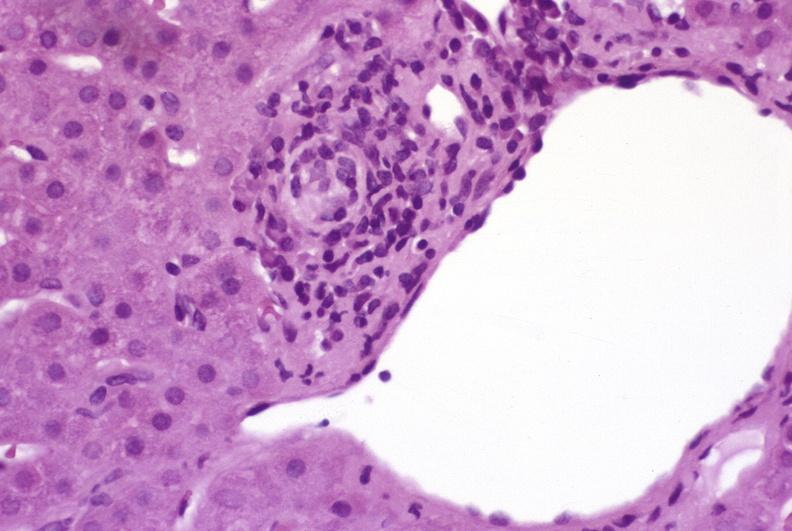does this image show mild-to-moderate acute rejection?
Answer the question using a single word or phrase. Yes 